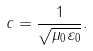<formula> <loc_0><loc_0><loc_500><loc_500>c = { \frac { 1 } { \sqrt { \mu _ { 0 } \varepsilon _ { 0 } } } } .</formula> 